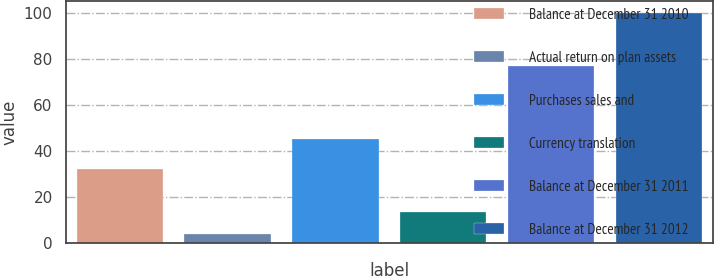Convert chart to OTSL. <chart><loc_0><loc_0><loc_500><loc_500><bar_chart><fcel>Balance at December 31 2010<fcel>Actual return on plan assets<fcel>Purchases sales and<fcel>Currency translation<fcel>Balance at December 31 2011<fcel>Balance at December 31 2012<nl><fcel>32<fcel>4<fcel>45<fcel>13.6<fcel>77<fcel>100<nl></chart> 